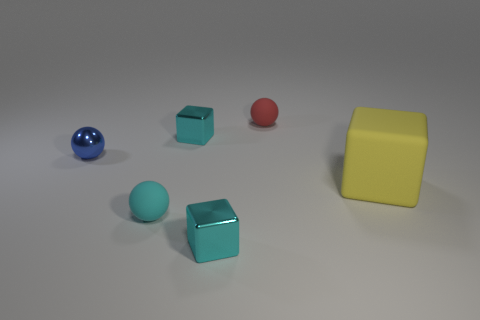Add 4 small cyan spheres. How many objects exist? 10 Add 4 blue shiny spheres. How many blue shiny spheres are left? 5 Add 2 purple metal things. How many purple metal things exist? 2 Subtract 0 green cylinders. How many objects are left? 6 Subtract all tiny cyan cylinders. Subtract all red matte objects. How many objects are left? 5 